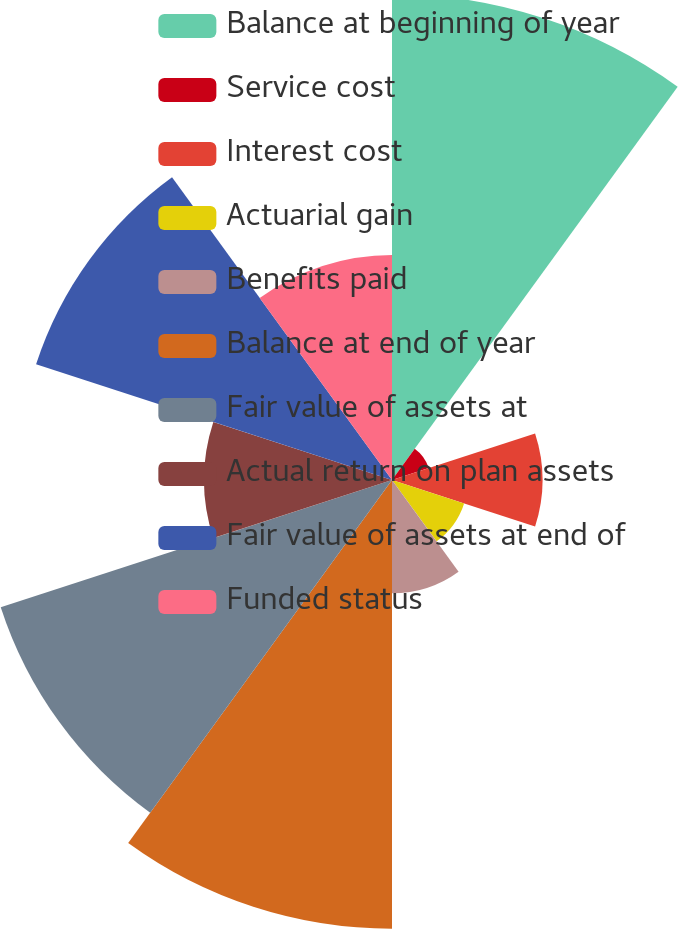Convert chart to OTSL. <chart><loc_0><loc_0><loc_500><loc_500><pie_chart><fcel>Balance at beginning of year<fcel>Service cost<fcel>Interest cost<fcel>Actuarial gain<fcel>Benefits paid<fcel>Balance at end of year<fcel>Fair value of assets at<fcel>Actual return on plan assets<fcel>Fair value of assets at end of<fcel>Funded status<nl><fcel>19.35%<fcel>1.54%<fcel>5.99%<fcel>3.02%<fcel>4.51%<fcel>17.87%<fcel>16.38%<fcel>7.48%<fcel>14.9%<fcel>8.96%<nl></chart> 